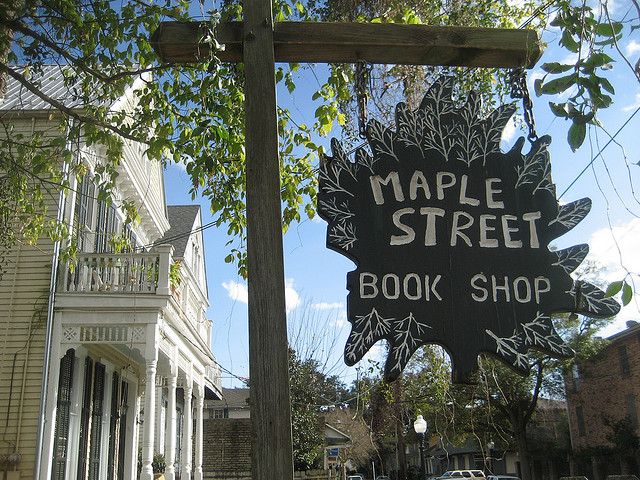Extract all visible text content from this image. MAPLE STREET BOOK SHOP 